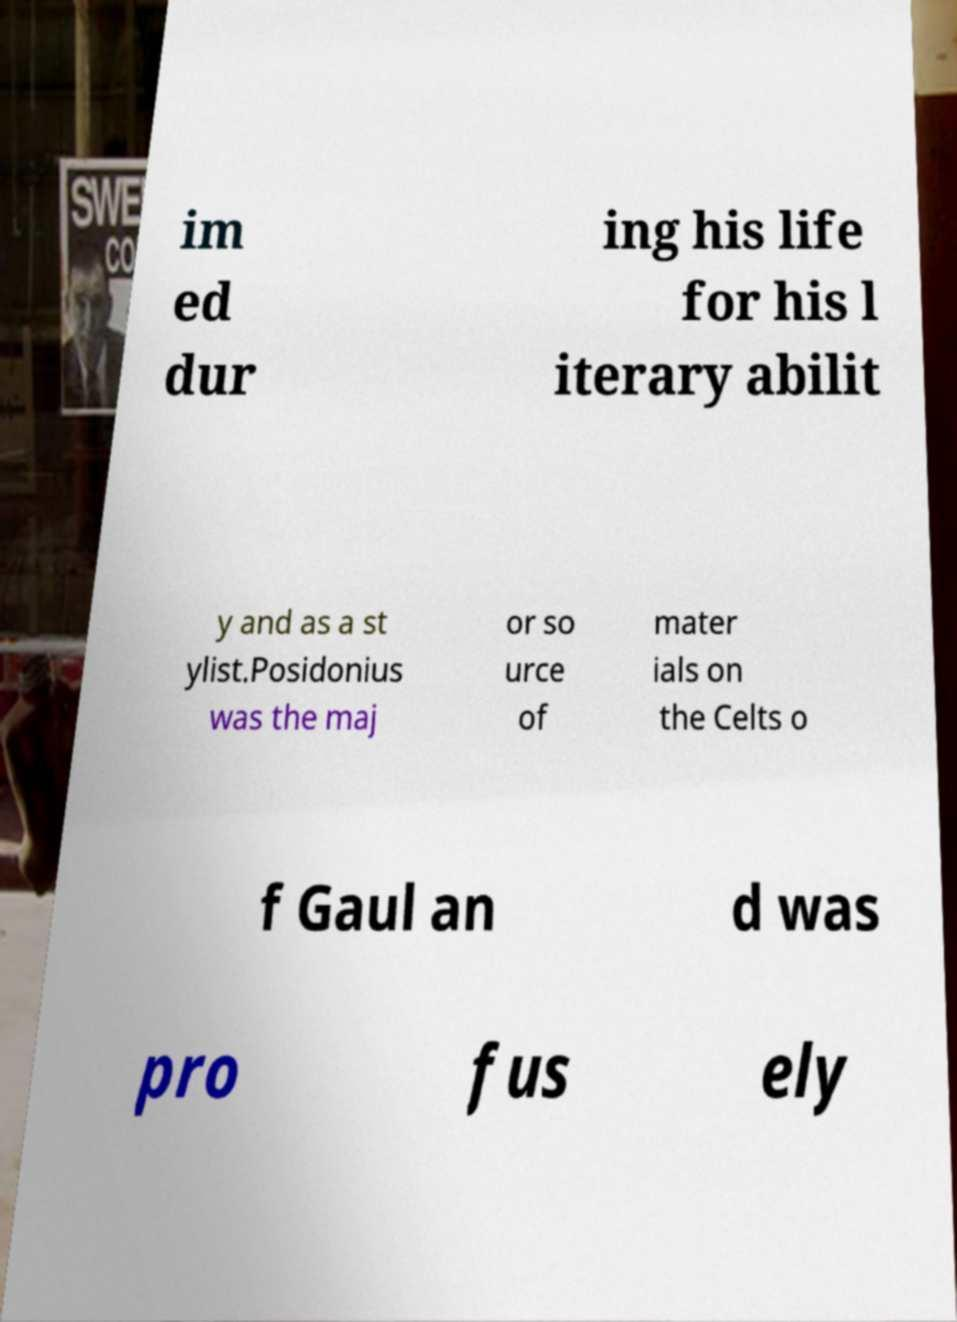I need the written content from this picture converted into text. Can you do that? im ed dur ing his life for his l iterary abilit y and as a st ylist.Posidonius was the maj or so urce of mater ials on the Celts o f Gaul an d was pro fus ely 